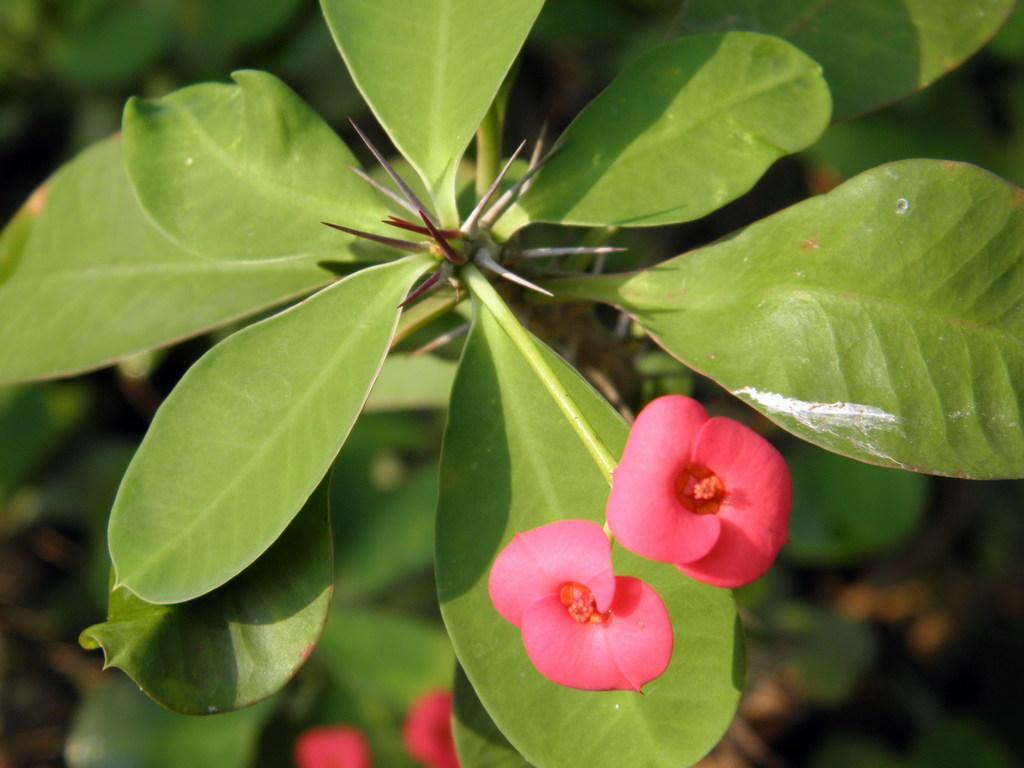In one or two sentences, can you explain what this image depicts? In the picture we can see a plant with huge leaves and two flowers which are pink in color. 